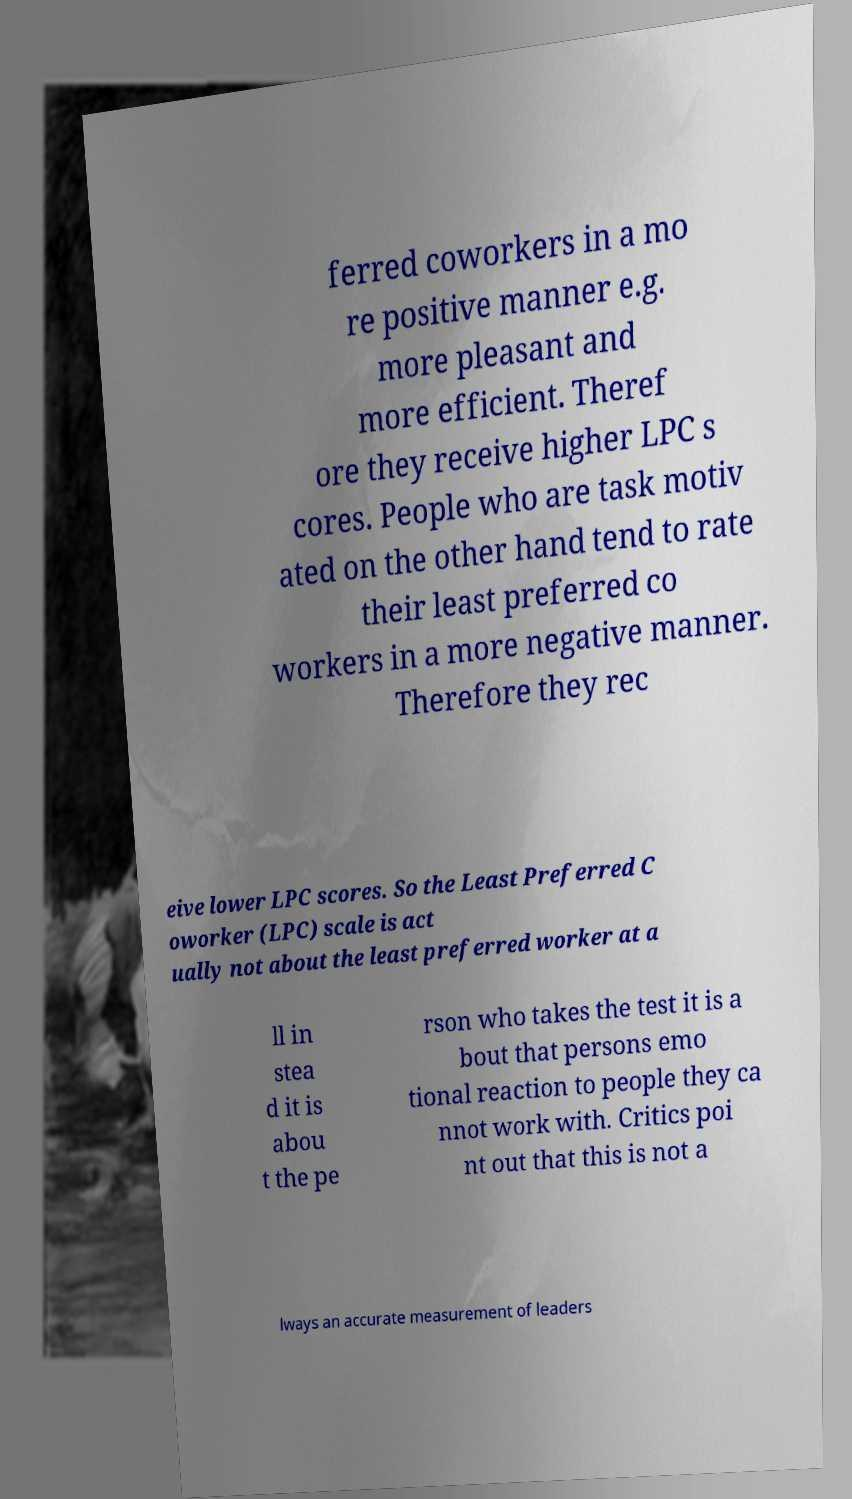Please identify and transcribe the text found in this image. ferred coworkers in a mo re positive manner e.g. more pleasant and more efficient. Theref ore they receive higher LPC s cores. People who are task motiv ated on the other hand tend to rate their least preferred co workers in a more negative manner. Therefore they rec eive lower LPC scores. So the Least Preferred C oworker (LPC) scale is act ually not about the least preferred worker at a ll in stea d it is abou t the pe rson who takes the test it is a bout that persons emo tional reaction to people they ca nnot work with. Critics poi nt out that this is not a lways an accurate measurement of leaders 